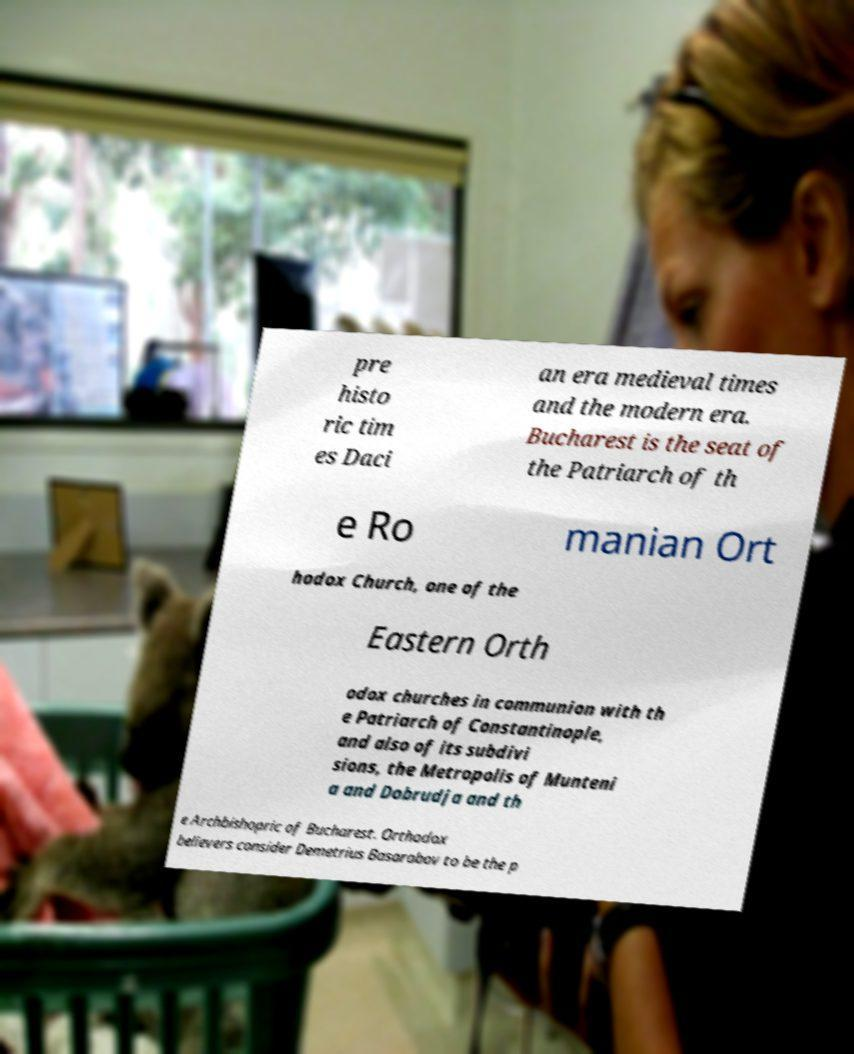There's text embedded in this image that I need extracted. Can you transcribe it verbatim? pre histo ric tim es Daci an era medieval times and the modern era. Bucharest is the seat of the Patriarch of th e Ro manian Ort hodox Church, one of the Eastern Orth odox churches in communion with th e Patriarch of Constantinople, and also of its subdivi sions, the Metropolis of Munteni a and Dobrudja and th e Archbishopric of Bucharest. Orthodox believers consider Demetrius Basarabov to be the p 